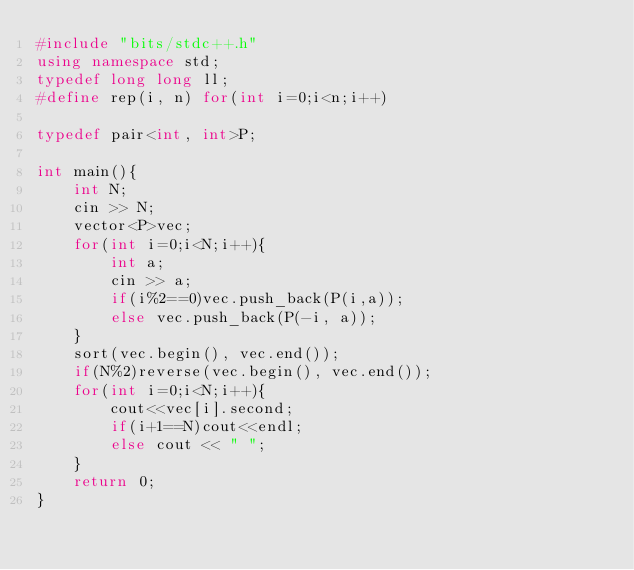Convert code to text. <code><loc_0><loc_0><loc_500><loc_500><_C++_>#include "bits/stdc++.h"
using namespace std;
typedef long long ll;
#define rep(i, n) for(int i=0;i<n;i++)

typedef pair<int, int>P;

int main(){
    int N;
    cin >> N;
    vector<P>vec;
    for(int i=0;i<N;i++){
        int a;
        cin >> a;
        if(i%2==0)vec.push_back(P(i,a));
        else vec.push_back(P(-i, a));
    }
    sort(vec.begin(), vec.end());
    if(N%2)reverse(vec.begin(), vec.end());
    for(int i=0;i<N;i++){
        cout<<vec[i].second;
        if(i+1==N)cout<<endl;
        else cout << " ";
    }
    return 0;
}</code> 